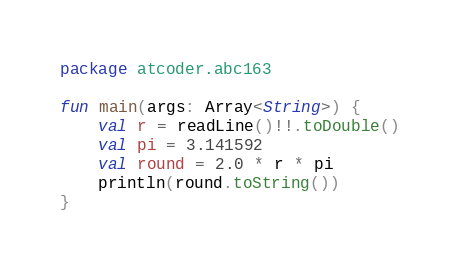<code> <loc_0><loc_0><loc_500><loc_500><_Kotlin_>package atcoder.abc163

fun main(args: Array<String>) {
    val r = readLine()!!.toDouble()
    val pi = 3.141592
    val round = 2.0 * r * pi
    println(round.toString())
}</code> 